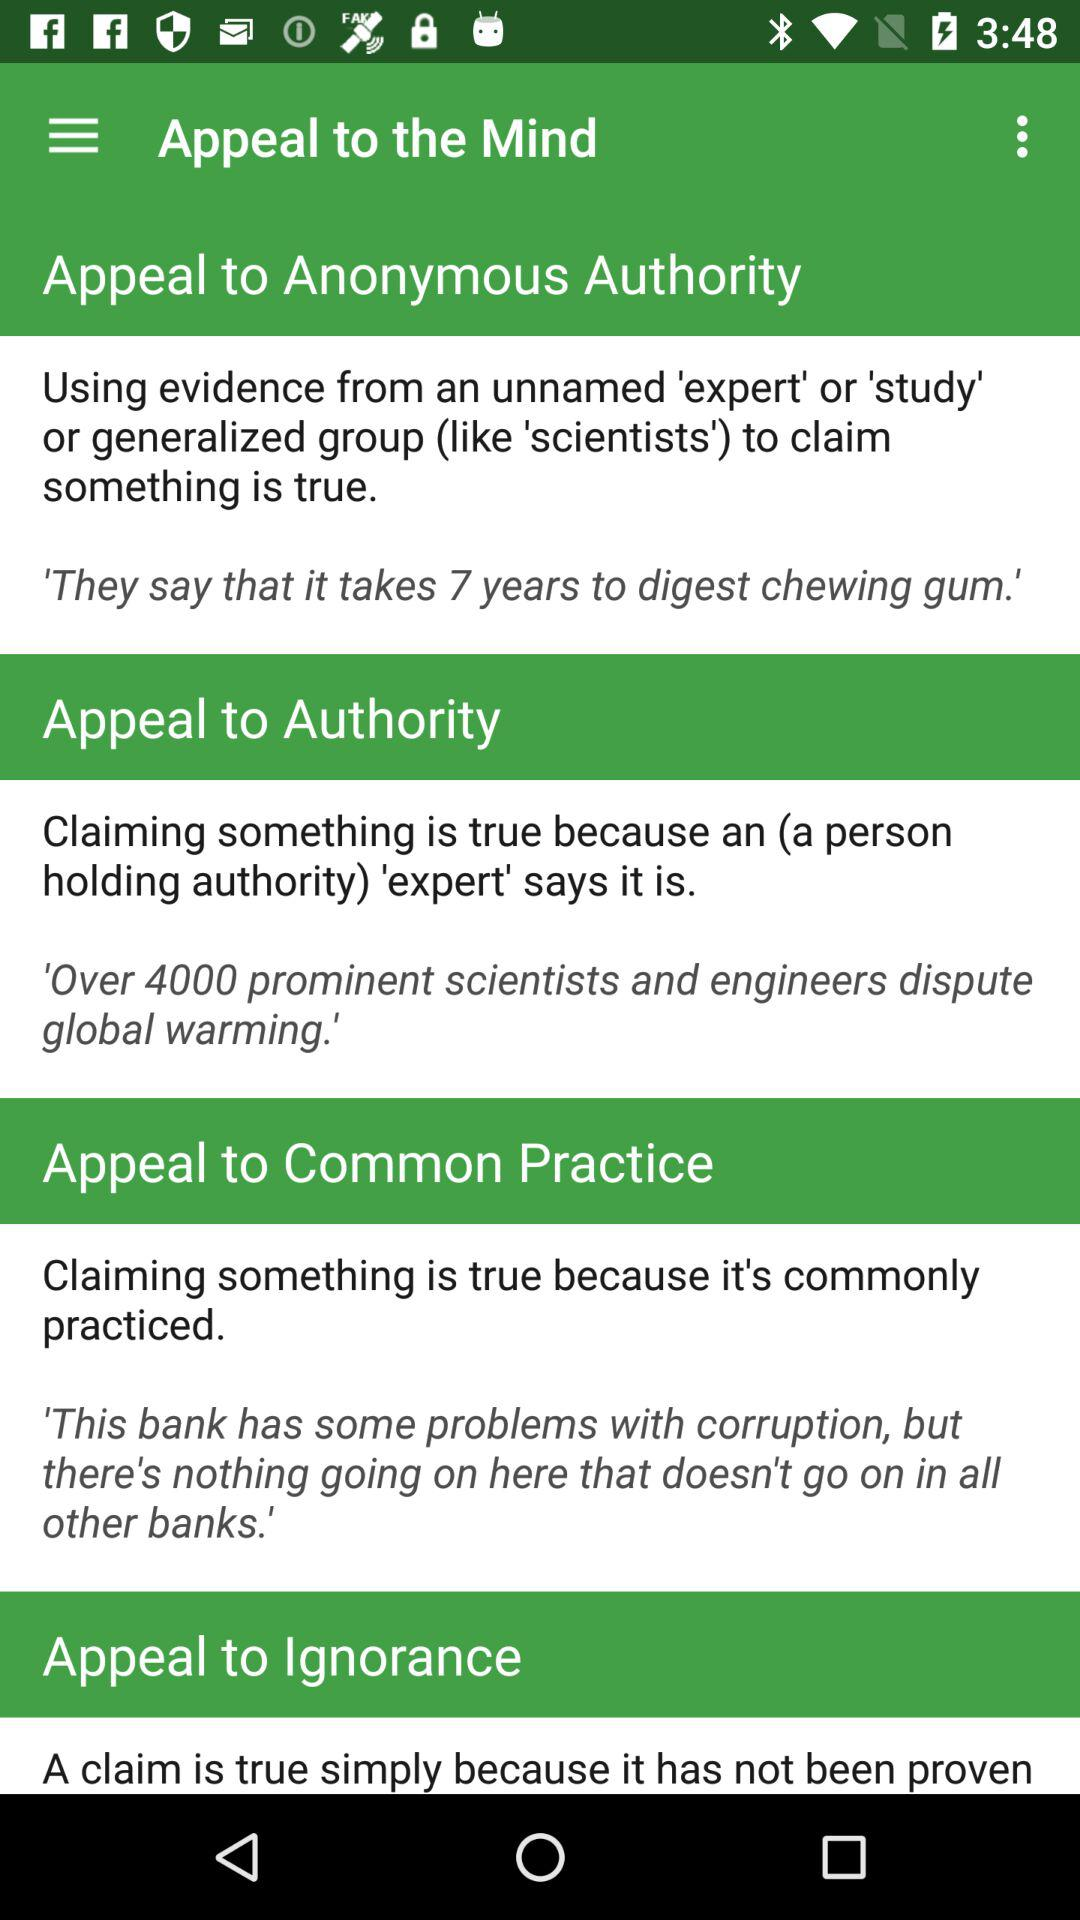How many prominent scientists and engineers dispute global warming? Over 4000 prominent scientists and engineers dispute global warming. 